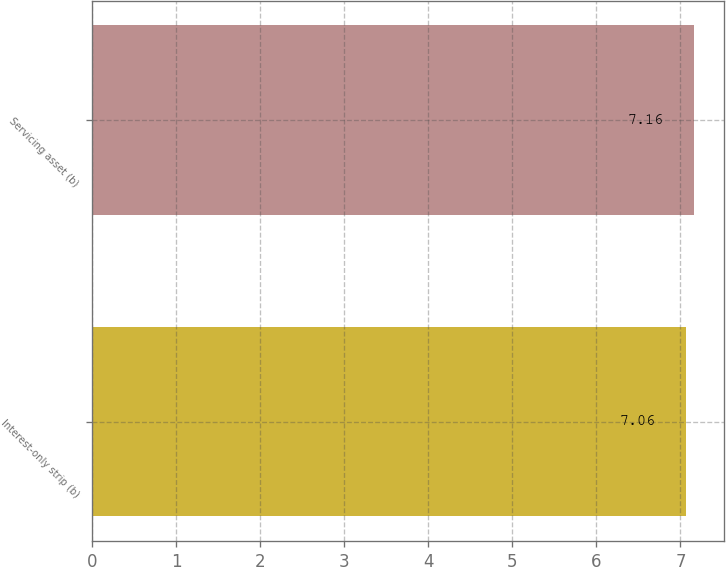Convert chart to OTSL. <chart><loc_0><loc_0><loc_500><loc_500><bar_chart><fcel>Interest-only strip (b)<fcel>Servicing asset (b)<nl><fcel>7.06<fcel>7.16<nl></chart> 